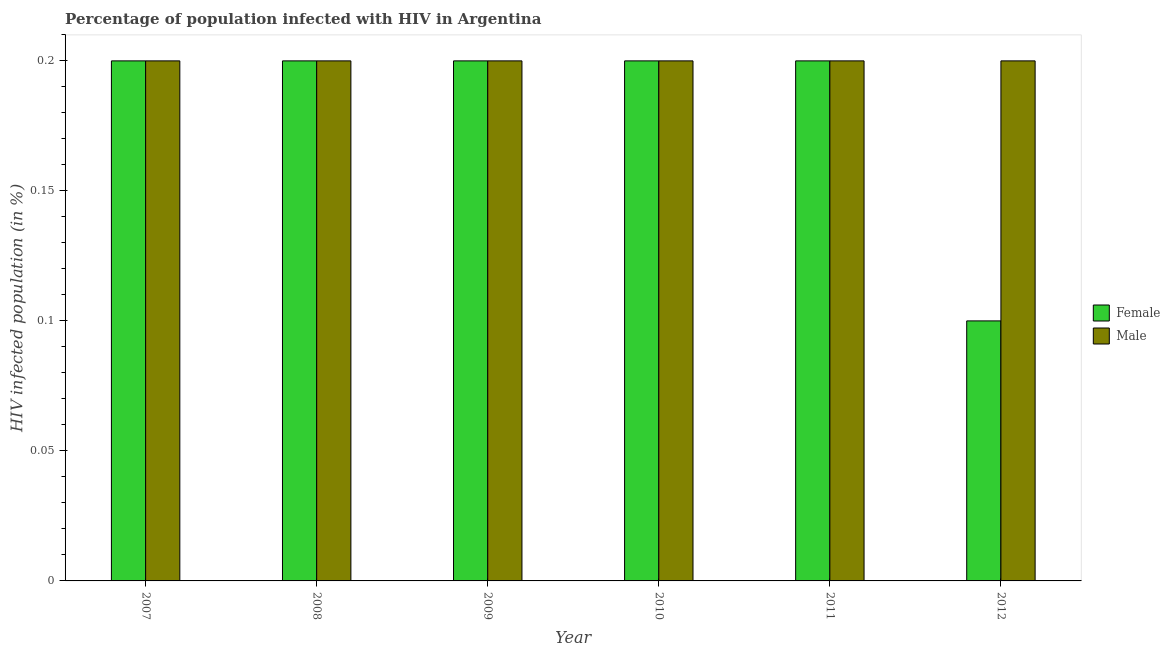Are the number of bars per tick equal to the number of legend labels?
Keep it short and to the point. Yes. Are the number of bars on each tick of the X-axis equal?
Make the answer very short. Yes. How many bars are there on the 1st tick from the left?
Provide a succinct answer. 2. How many bars are there on the 6th tick from the right?
Offer a very short reply. 2. Across all years, what is the minimum percentage of females who are infected with hiv?
Your response must be concise. 0.1. In which year was the percentage of males who are infected with hiv maximum?
Provide a succinct answer. 2007. What is the total percentage of males who are infected with hiv in the graph?
Ensure brevity in your answer.  1.2. What is the average percentage of females who are infected with hiv per year?
Your answer should be compact. 0.18. In how many years, is the percentage of males who are infected with hiv greater than 0.05 %?
Your answer should be very brief. 6. Is the percentage of males who are infected with hiv in 2008 less than that in 2012?
Make the answer very short. No. What is the difference between the highest and the second highest percentage of males who are infected with hiv?
Your answer should be compact. 0. Is the sum of the percentage of females who are infected with hiv in 2008 and 2009 greater than the maximum percentage of males who are infected with hiv across all years?
Offer a very short reply. Yes. What does the 1st bar from the right in 2008 represents?
Your answer should be compact. Male. What is the difference between two consecutive major ticks on the Y-axis?
Give a very brief answer. 0.05. Are the values on the major ticks of Y-axis written in scientific E-notation?
Your answer should be very brief. No. Does the graph contain any zero values?
Provide a short and direct response. No. Does the graph contain grids?
Your answer should be compact. No. What is the title of the graph?
Provide a succinct answer. Percentage of population infected with HIV in Argentina. What is the label or title of the X-axis?
Make the answer very short. Year. What is the label or title of the Y-axis?
Your answer should be compact. HIV infected population (in %). What is the HIV infected population (in %) in Female in 2007?
Offer a very short reply. 0.2. What is the HIV infected population (in %) in Male in 2007?
Keep it short and to the point. 0.2. What is the HIV infected population (in %) in Female in 2008?
Keep it short and to the point. 0.2. What is the HIV infected population (in %) of Female in 2010?
Give a very brief answer. 0.2. What is the HIV infected population (in %) in Male in 2010?
Make the answer very short. 0.2. What is the HIV infected population (in %) in Male in 2011?
Ensure brevity in your answer.  0.2. What is the HIV infected population (in %) of Female in 2012?
Your response must be concise. 0.1. What is the total HIV infected population (in %) in Male in the graph?
Keep it short and to the point. 1.2. What is the difference between the HIV infected population (in %) in Female in 2007 and that in 2010?
Your answer should be compact. 0. What is the difference between the HIV infected population (in %) of Male in 2007 and that in 2012?
Offer a very short reply. 0. What is the difference between the HIV infected population (in %) of Female in 2008 and that in 2010?
Your answer should be very brief. 0. What is the difference between the HIV infected population (in %) in Male in 2008 and that in 2010?
Your answer should be compact. 0. What is the difference between the HIV infected population (in %) of Female in 2009 and that in 2010?
Your answer should be compact. 0. What is the difference between the HIV infected population (in %) of Female in 2009 and that in 2011?
Keep it short and to the point. 0. What is the difference between the HIV infected population (in %) in Female in 2009 and that in 2012?
Your response must be concise. 0.1. What is the difference between the HIV infected population (in %) in Male in 2010 and that in 2011?
Keep it short and to the point. 0. What is the difference between the HIV infected population (in %) in Female in 2010 and that in 2012?
Ensure brevity in your answer.  0.1. What is the difference between the HIV infected population (in %) in Male in 2010 and that in 2012?
Make the answer very short. 0. What is the difference between the HIV infected population (in %) of Male in 2011 and that in 2012?
Offer a terse response. 0. What is the difference between the HIV infected population (in %) of Female in 2007 and the HIV infected population (in %) of Male in 2008?
Offer a very short reply. 0. What is the difference between the HIV infected population (in %) of Female in 2007 and the HIV infected population (in %) of Male in 2009?
Your answer should be very brief. 0. What is the difference between the HIV infected population (in %) in Female in 2007 and the HIV infected population (in %) in Male in 2010?
Your answer should be compact. 0. What is the difference between the HIV infected population (in %) of Female in 2008 and the HIV infected population (in %) of Male in 2011?
Make the answer very short. 0. What is the difference between the HIV infected population (in %) in Female in 2008 and the HIV infected population (in %) in Male in 2012?
Ensure brevity in your answer.  0. What is the difference between the HIV infected population (in %) of Female in 2009 and the HIV infected population (in %) of Male in 2010?
Give a very brief answer. 0. What is the difference between the HIV infected population (in %) of Female in 2010 and the HIV infected population (in %) of Male in 2011?
Your answer should be very brief. 0. What is the difference between the HIV infected population (in %) of Female in 2010 and the HIV infected population (in %) of Male in 2012?
Make the answer very short. 0. What is the difference between the HIV infected population (in %) in Female in 2011 and the HIV infected population (in %) in Male in 2012?
Provide a succinct answer. 0. What is the average HIV infected population (in %) in Female per year?
Keep it short and to the point. 0.18. In the year 2007, what is the difference between the HIV infected population (in %) in Female and HIV infected population (in %) in Male?
Your response must be concise. 0. In the year 2008, what is the difference between the HIV infected population (in %) of Female and HIV infected population (in %) of Male?
Make the answer very short. 0. In the year 2009, what is the difference between the HIV infected population (in %) in Female and HIV infected population (in %) in Male?
Give a very brief answer. 0. What is the ratio of the HIV infected population (in %) of Female in 2007 to that in 2009?
Offer a terse response. 1. What is the ratio of the HIV infected population (in %) in Female in 2007 to that in 2010?
Your answer should be very brief. 1. What is the ratio of the HIV infected population (in %) of Male in 2007 to that in 2011?
Your response must be concise. 1. What is the ratio of the HIV infected population (in %) of Female in 2007 to that in 2012?
Provide a succinct answer. 2. What is the ratio of the HIV infected population (in %) in Male in 2008 to that in 2009?
Your answer should be very brief. 1. What is the ratio of the HIV infected population (in %) of Female in 2008 to that in 2011?
Offer a terse response. 1. What is the ratio of the HIV infected population (in %) in Male in 2008 to that in 2011?
Ensure brevity in your answer.  1. What is the ratio of the HIV infected population (in %) in Female in 2008 to that in 2012?
Ensure brevity in your answer.  2. What is the ratio of the HIV infected population (in %) in Male in 2009 to that in 2010?
Make the answer very short. 1. What is the ratio of the HIV infected population (in %) in Male in 2009 to that in 2011?
Provide a succinct answer. 1. What is the ratio of the HIV infected population (in %) of Female in 2009 to that in 2012?
Provide a short and direct response. 2. What is the ratio of the HIV infected population (in %) in Male in 2010 to that in 2011?
Offer a very short reply. 1. What is the ratio of the HIV infected population (in %) in Female in 2010 to that in 2012?
Offer a very short reply. 2. What is the ratio of the HIV infected population (in %) in Male in 2011 to that in 2012?
Your answer should be very brief. 1. What is the difference between the highest and the second highest HIV infected population (in %) in Female?
Make the answer very short. 0. What is the difference between the highest and the second highest HIV infected population (in %) of Male?
Your response must be concise. 0. 